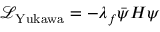Convert formula to latex. <formula><loc_0><loc_0><loc_500><loc_500>{ \mathcal { L } } _ { Y u k a w a } = - \lambda _ { f } { \bar { \psi } } H \psi</formula> 